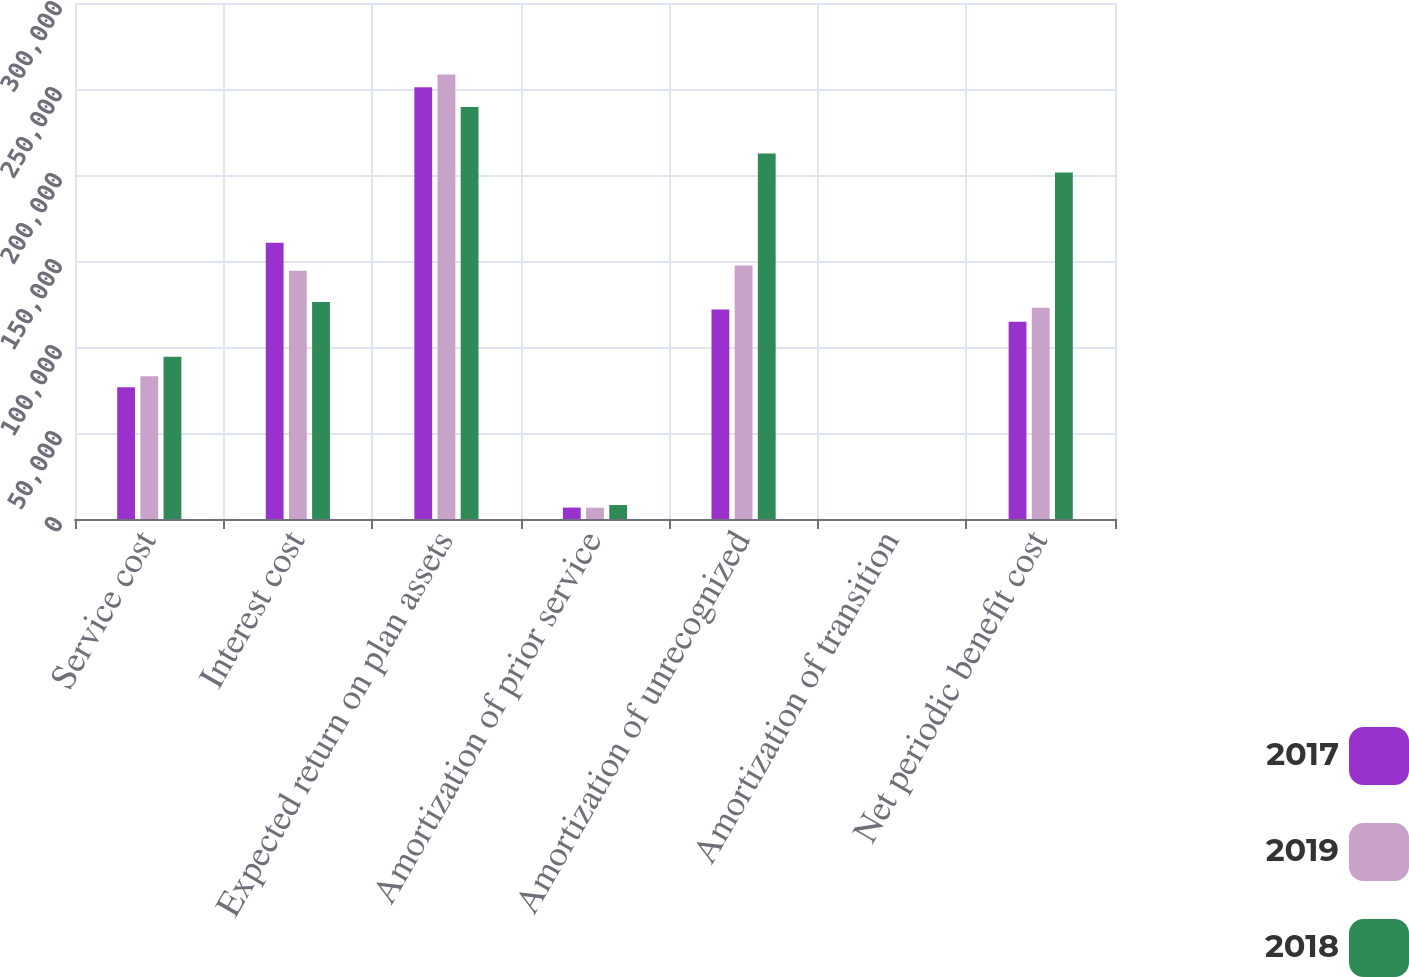Convert chart to OTSL. <chart><loc_0><loc_0><loc_500><loc_500><stacked_bar_chart><ecel><fcel>Service cost<fcel>Interest cost<fcel>Expected return on plan assets<fcel>Amortization of prior service<fcel>Amortization of unrecognized<fcel>Amortization of transition<fcel>Net periodic benefit cost<nl><fcel>2017<fcel>76647<fcel>160542<fcel>251072<fcel>6655<fcel>121823<fcel>18<fcel>114613<nl><fcel>2019<fcel>82993<fcel>144339<fcel>258490<fcel>6570<fcel>147387<fcel>18<fcel>122817<nl><fcel>2018<fcel>94356<fcel>126131<fcel>239537<fcel>8116<fcel>212433<fcel>18<fcel>201517<nl></chart> 